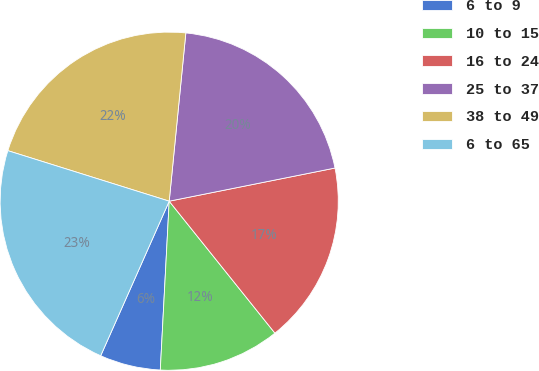Convert chart to OTSL. <chart><loc_0><loc_0><loc_500><loc_500><pie_chart><fcel>6 to 9<fcel>10 to 15<fcel>16 to 24<fcel>25 to 37<fcel>38 to 49<fcel>6 to 65<nl><fcel>5.8%<fcel>11.59%<fcel>17.39%<fcel>20.29%<fcel>21.74%<fcel>23.19%<nl></chart> 